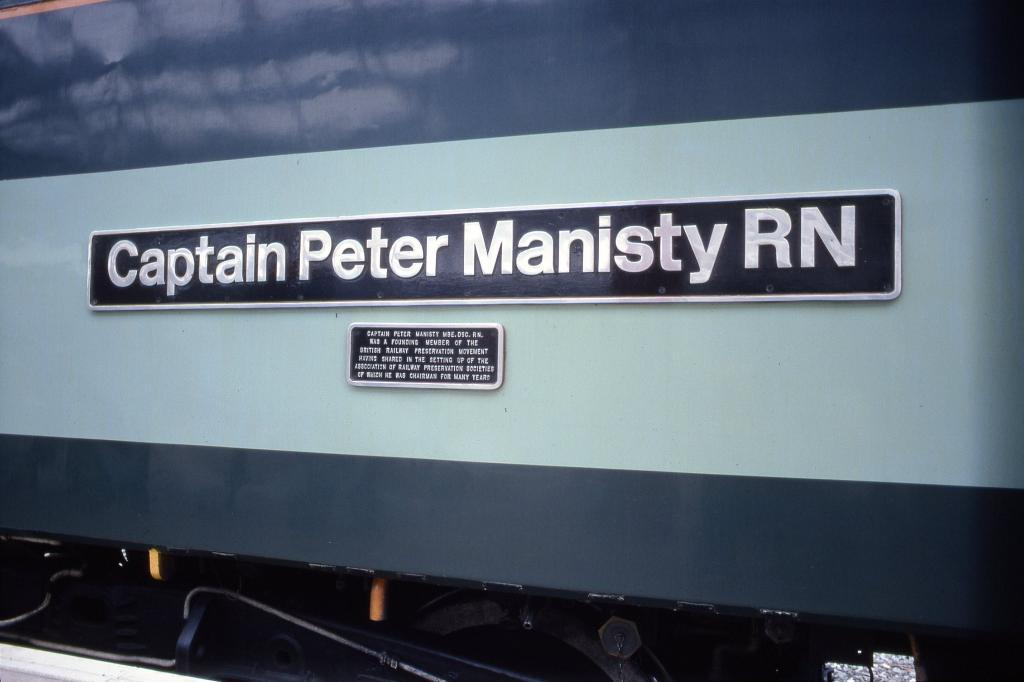What is the main subject of the image? The main subject of the image is an object that resembles a train. What can be seen on the train in the image? There are boards on the train. What is written or depicted on the boards? There is text on the boards. How does the oven compare to the train in the image? There is no oven present in the image, so it cannot be compared to the train. 